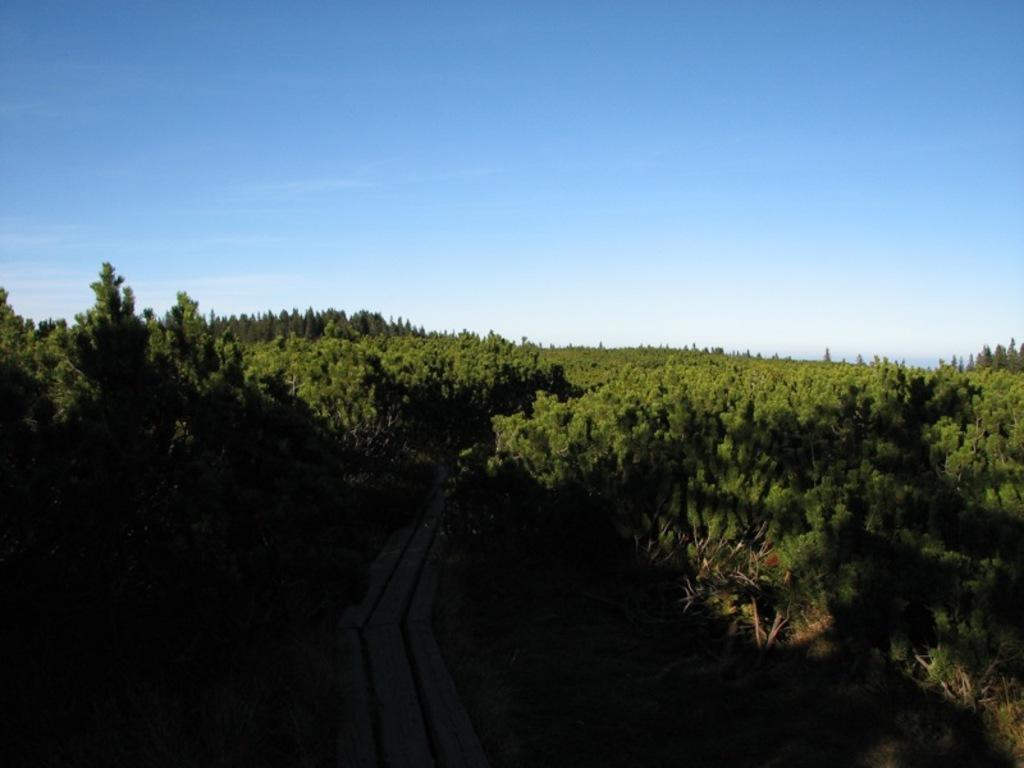What is the main subject of the image? The main subject of the image is a railway track. Where is the railway track located? The railway track is located between a forest area. Can you describe the forest area? The forest area is covered with trees and plants. What can be seen in the background of the image? The sky is visible in the background of the image. What is the color of the sky in the image? The sky is blue in color. How many ants can be seen carrying leaves on the railway track in the image? There are no ants visible in the image, and therefore no ants carrying leaves can be observed. What is the result of adding 5 and 7 in the image? There is no mathematical operation or result shown in the image. 